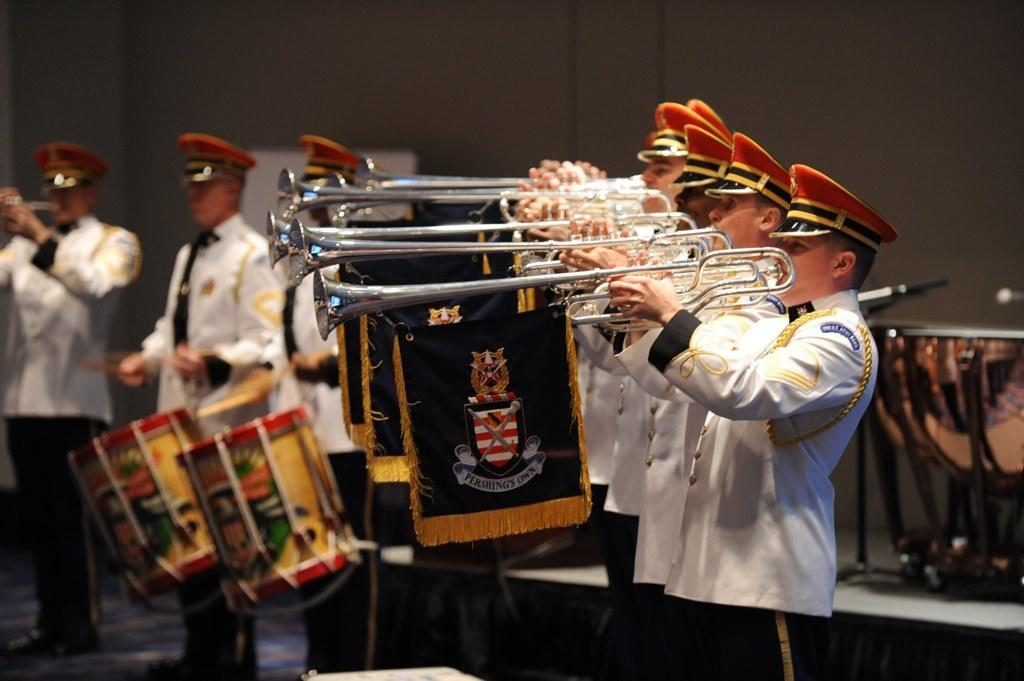What can be seen in the background of the image? There is a wall in the background of the image. What are the men in the image doing? The men are playing musical instruments. Can you describe any specific musical instruments in the image? Yes, there is a drum visible in the background of the image. What type of writing can be seen on the wall in the image? There is no writing visible on the wall in the image. Is the road visible in the image? There is no road present in the image. 